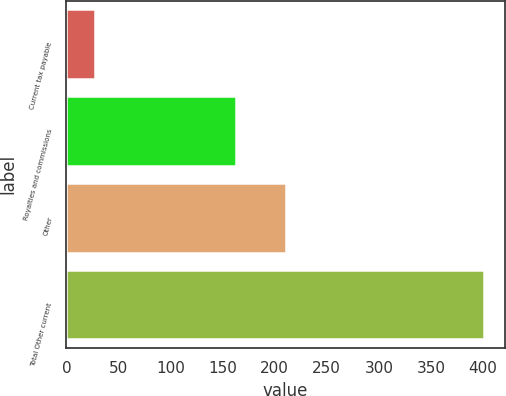Convert chart. <chart><loc_0><loc_0><loc_500><loc_500><bar_chart><fcel>Current tax payable<fcel>Royalties and commissions<fcel>Other<fcel>Total Other current<nl><fcel>27<fcel>163<fcel>211<fcel>401<nl></chart> 